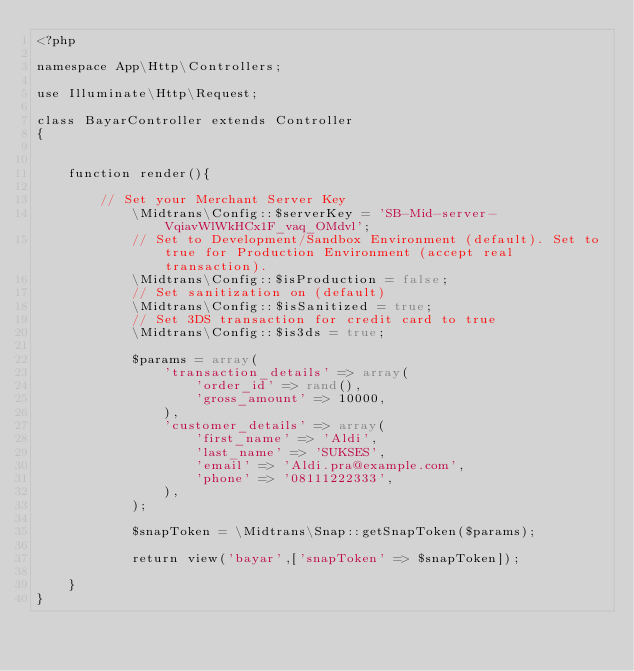Convert code to text. <code><loc_0><loc_0><loc_500><loc_500><_PHP_><?php

namespace App\Http\Controllers;

use Illuminate\Http\Request;

class BayarController extends Controller
{
    

    function render(){

    	// Set your Merchant Server Key
			\Midtrans\Config::$serverKey = 'SB-Mid-server-VqiavWlWkHCx1F_vaq_OMdvl';
			// Set to Development/Sandbox Environment (default). Set to true for Production Environment (accept real transaction).
			\Midtrans\Config::$isProduction = false;
			// Set sanitization on (default)
			\Midtrans\Config::$isSanitized = true;
			// Set 3DS transaction for credit card to true
			\Midtrans\Config::$is3ds = true;
			 
			$params = array(
			    'transaction_details' => array(
			        'order_id' => rand(),
			        'gross_amount' => 10000,
			    ),
			    'customer_details' => array(
			        'first_name' => 'Aldi',
			        'last_name' => 'SUKSES',
			        'email' => 'Aldi.pra@example.com',
			        'phone' => '08111222333',
			    ),
			);
			 
			$snapToken = \Midtrans\Snap::getSnapToken($params);

			return view('bayar',['snapToken' => $snapToken]);

    }
}
</code> 